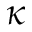Convert formula to latex. <formula><loc_0><loc_0><loc_500><loc_500>\kappa</formula> 